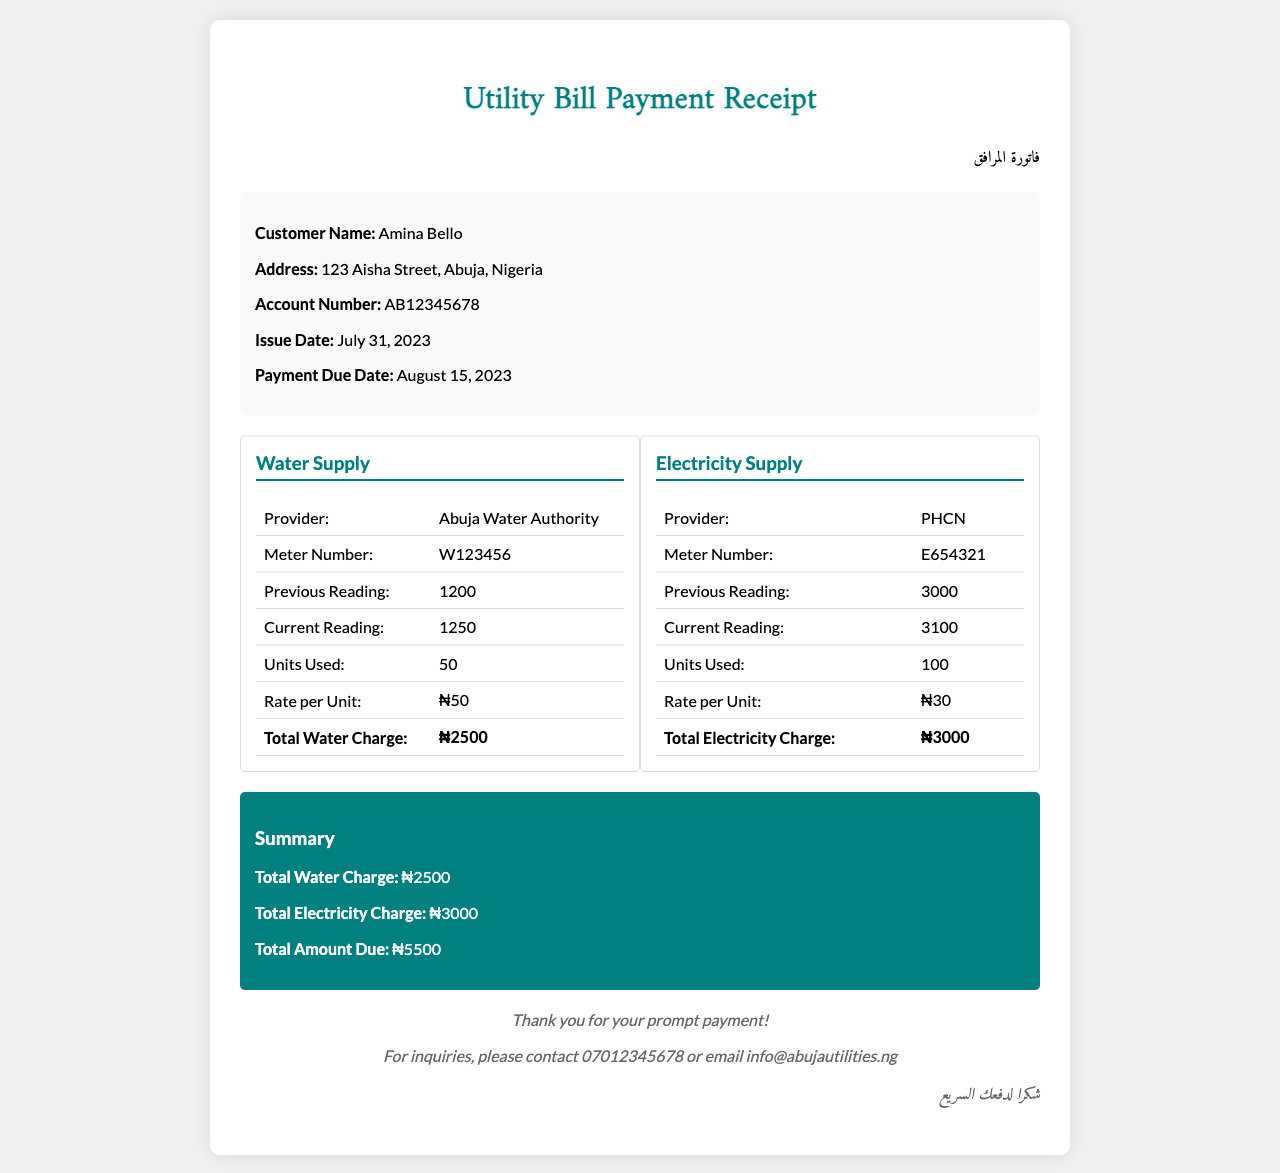What is the customer name? The customer's name is listed in the document under customer info.
Answer: Amina Bello What is the issue date of the receipt? The issue date is provided in the customer information section of the document.
Answer: July 31, 2023 What is the total amount due? The total amount due is the sum of the water and electricity charges specified in the summary section.
Answer: ₦5500 What is the water charge per unit? The rate per unit of water is mentioned in the water supply section of the document.
Answer: ₦50 How many units of electricity were used? The document specifies the total units of electricity used in the electricity supply section.
Answer: 100 What is the provider of the electricity supply? The provider for electricity is stated in the electricity supply section of the document.
Answer: PHCN What is the meter number for water supply? The water meter number is recorded in the water supply section of the utility details.
Answer: W123456 What is the previous reading for electricity? Previous readings are listed in the electricity supply section of the document.
Answer: 3000 What is the total charge for water? The total water charge is provided in the water supply summary table.
Answer: ₦2500 